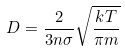<formula> <loc_0><loc_0><loc_500><loc_500>D = \frac { 2 } { 3 n \sigma } \sqrt { \frac { k T } { \pi m } }</formula> 